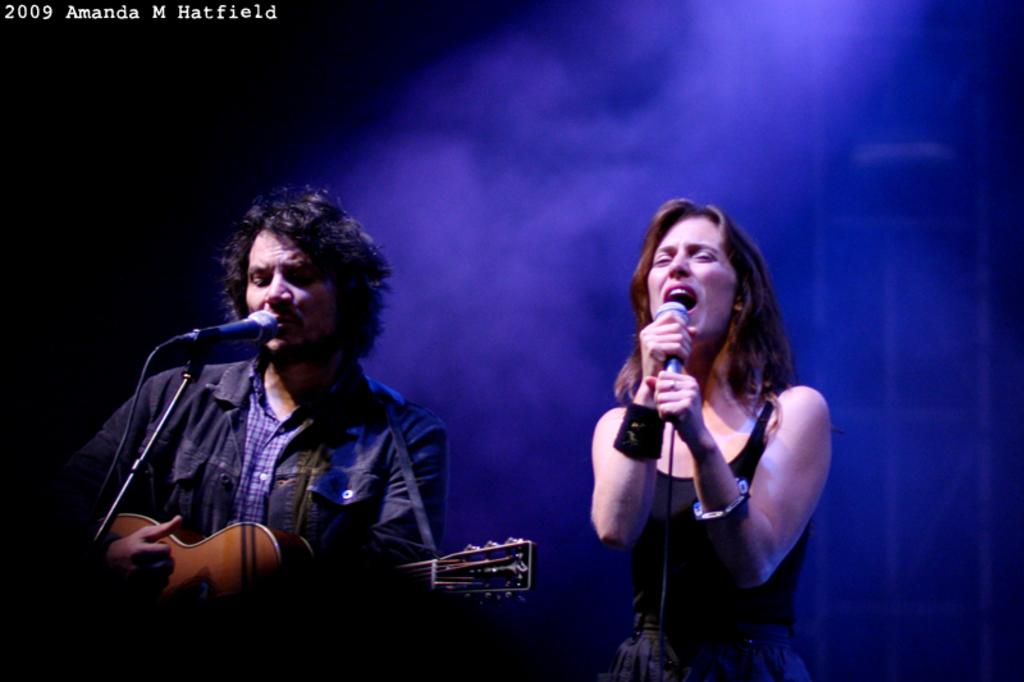How many people are present in the image? There is a man and a woman in the image. What object can be seen in the image that is typically used for making music? There is a guitar in the image. What equipment is present in the image that is used for amplifying sound? There are microphones in the image. What can be said about the lighting conditions in the image? The background of the image is dark. What is visible in the top left corner of the image? There is some text visible in the top left corner of the image. How many cars are parked behind the man in the image? There are no cars visible in the image. Is there a connection between the man and the woman in the image? The image does not provide any information about a connection between the man and the woman. Can you see any ants crawling on the guitar in the image? There are no ants visible in the image. 